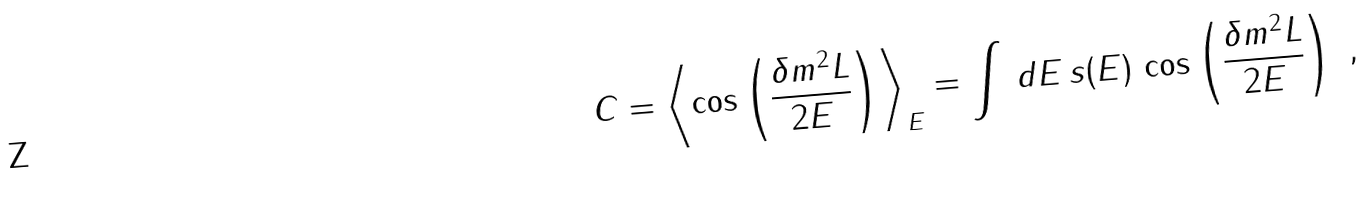Convert formula to latex. <formula><loc_0><loc_0><loc_500><loc_500>C = \left \langle \cos \left ( \frac { \delta m ^ { 2 } L } { 2 E } \right ) \right \rangle _ { E } = \int \, d E \, s ( E ) \, \cos \left ( \frac { \delta m ^ { 2 } L } { 2 E } \right ) \ ,</formula> 